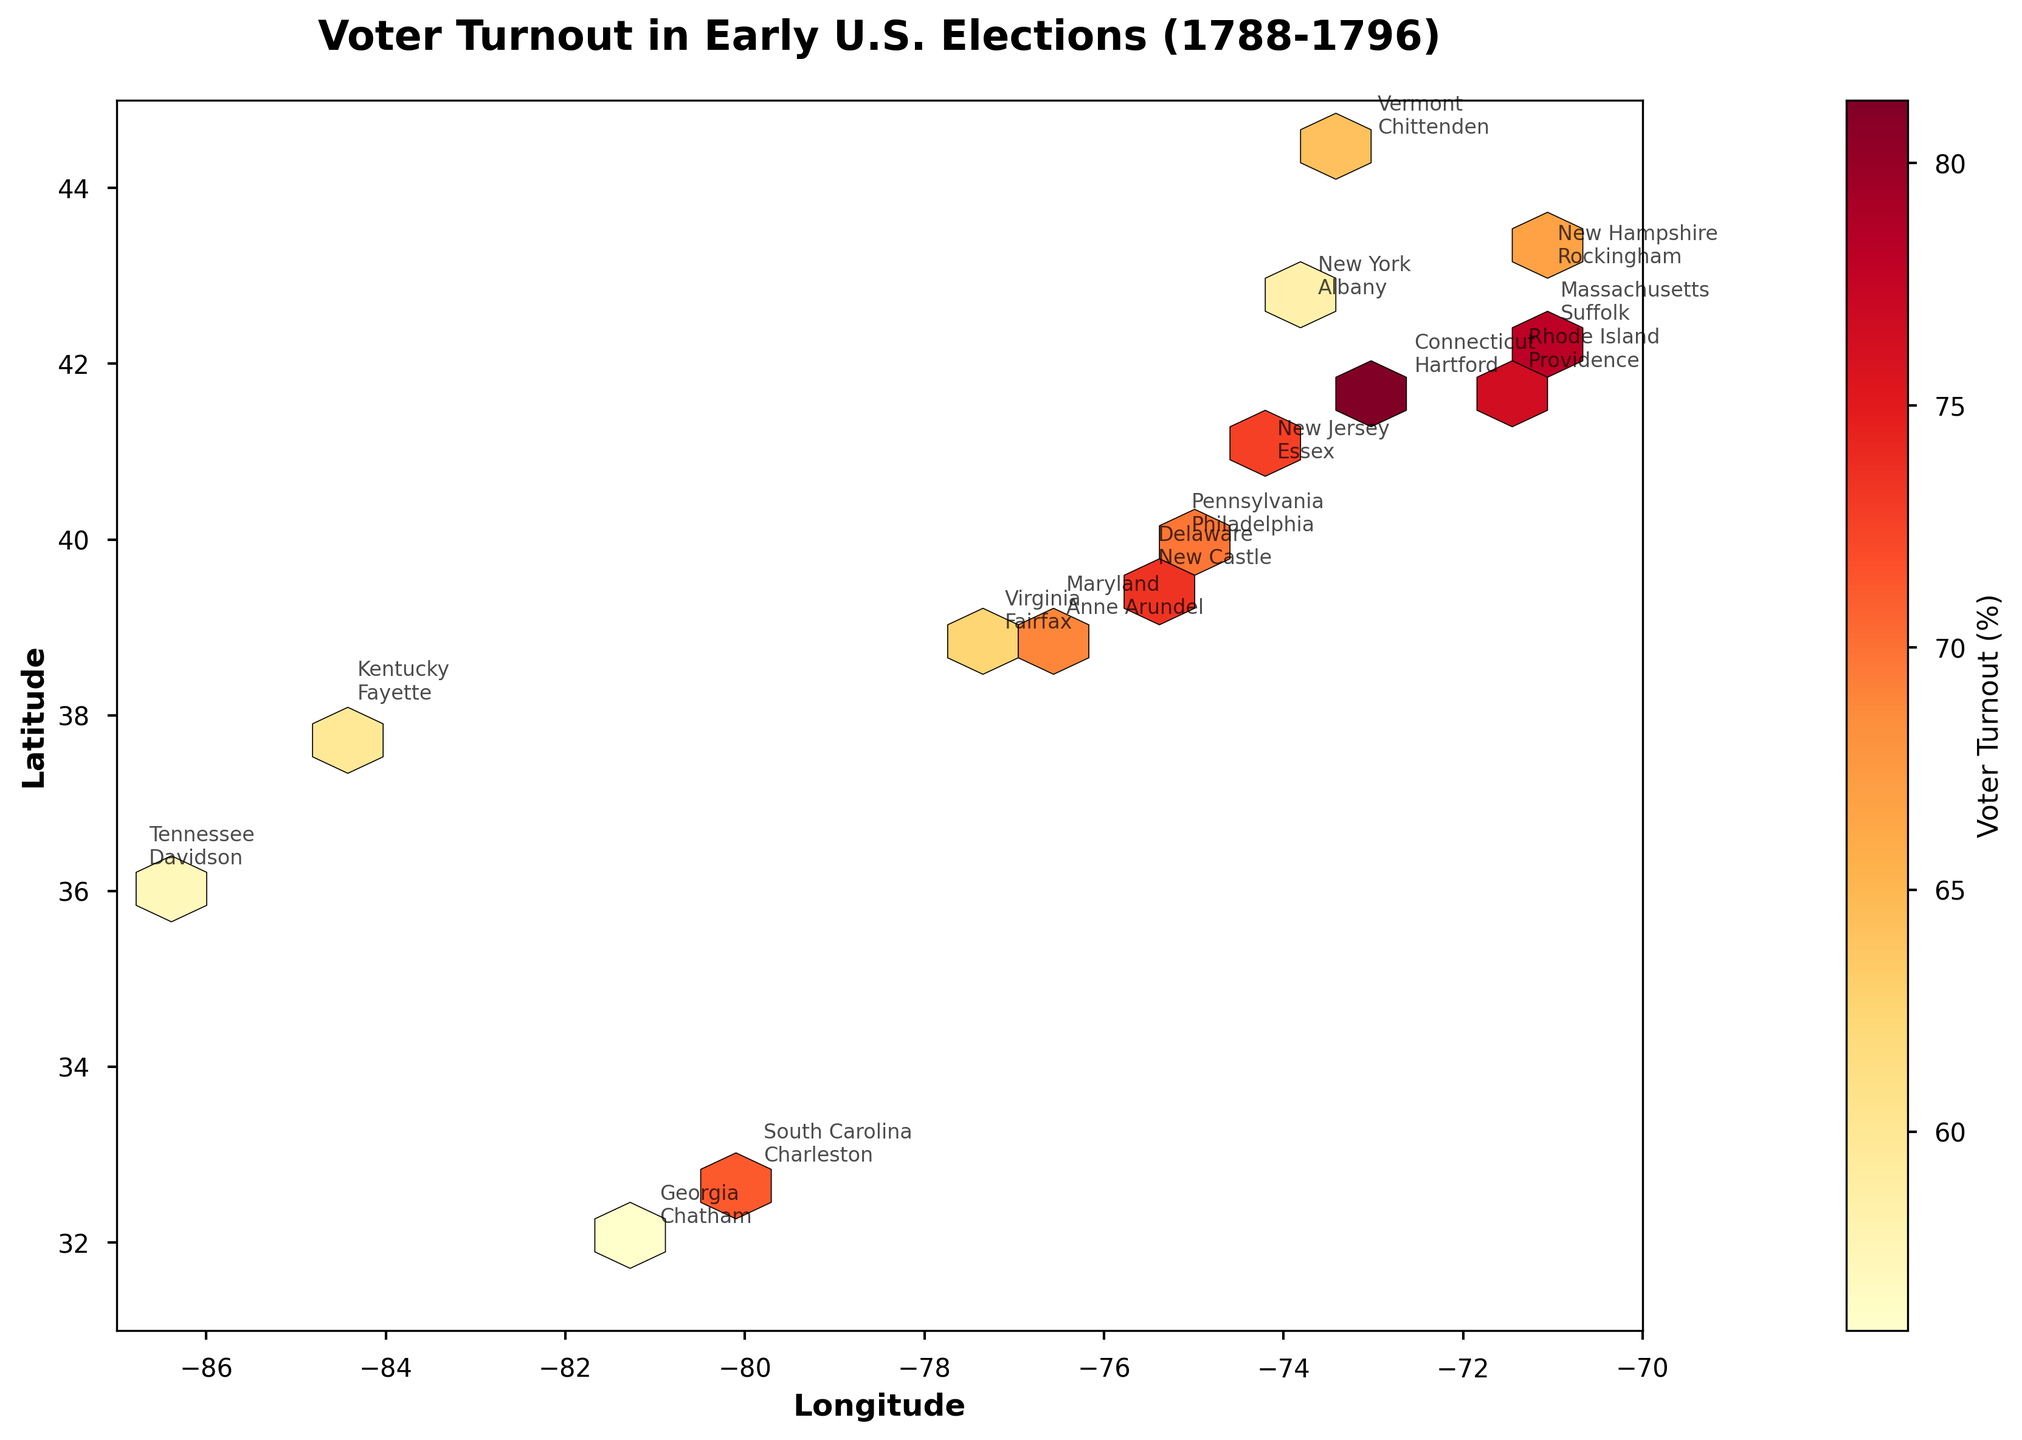What is the title of the figure? The title of the plot is typically placed at the top and in bold text. It helps provide context for what the plot is visualizing.
Answer: Voter Turnout in Early U.S. Elections (1788-1796) What colors are used to depict voter turnout in the figure? The colors in the hexbin plot range from shades of yellow to shades of red, which are typically used to show varying densities or quantities, with red usually representing higher values and yellow representing lower values.
Answer: Shades of yellow and red How many hexagonal bins are used to display the data? The plot's hexagonal bins are based on a gridsize parameter, which in this case is set to 20. This gives a reasonable resolution to visualize the spatial distribution of voter turnout.
Answer: 20 Which state has the highest voter turnout and what is it? By looking at the color legend and corresponding hexagon in the plot, we can see that Hartford, Connecticut, marked with a color on the higher end of the scale, has the highest voter turnout. The voter turnout for Hartford is 81.3%.
Answer: Connecticut, 81.3% What are the longitude and latitude ranges covered by this plot? The plot boundaries for longitude and latitude can be determined by observing the x-axis and y-axis limits. The x-axis (longitude) ranges from -87 to -70, and the y-axis (latitude) ranges from 31 to 45.
Answer: Longitude: -87 to -70, Latitude: 31 to 45 Which states have a higher voter turnout, southern or northern states? By observing the colors of hexagons, typically with northern states being more towards red or dark orange, indicating higher voter turnout, while southern states tend to be yellowish. This general trend shows northern states had higher voter turnout in early U.S. elections.
Answer: Northern states Which neighboring states show a consistent voting pattern in terms of voter turnout? Massachusetts and Connecticut both have very high voter turnout, showing a consistency in the voting pattern as indicated by similar colors (toward red) on their respective hexagons.
Answer: Massachusetts and Connecticut What can you infer about the voter turnout for the state at the coordinates (-71.0589, 42.3601)? Checking the plot, these coordinate points correspond to Suffolk, Massachusetts. This state is represented with a dark color, implying a high voter turnout. The table confirms a voter turnout of 78.1%.
Answer: It is high, 78.1% How does the voter turnout in New York compare to that in Pennsylvania? By observing the shades of the hexagons representing Albany, New York, and Philadelphia, Pennsylvania, we compare their colors. Albany's hexagon is lighter than Philadelphia's, indicating a lower voter turnout in New York (58.3%) compared to Pennsylvania (69.7%).
Answer: Pennsylvania has a higher turnout Which state had the closest voter turnout percentage in consecutive elections, and what are those percentages? From the data and a close observation of hexbin colors and annotations, Delaware (New Castle) and Maryland (Anne Arundel) had turnouts of 73.4% and 68.9% respectively in the 1792 election, showing close voter turnout percentages.
Answer: Delaware (73.4%) and Maryland (68.9%) 